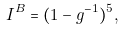<formula> <loc_0><loc_0><loc_500><loc_500>I ^ { B } = ( 1 - g ^ { - 1 } ) ^ { 5 } ,</formula> 